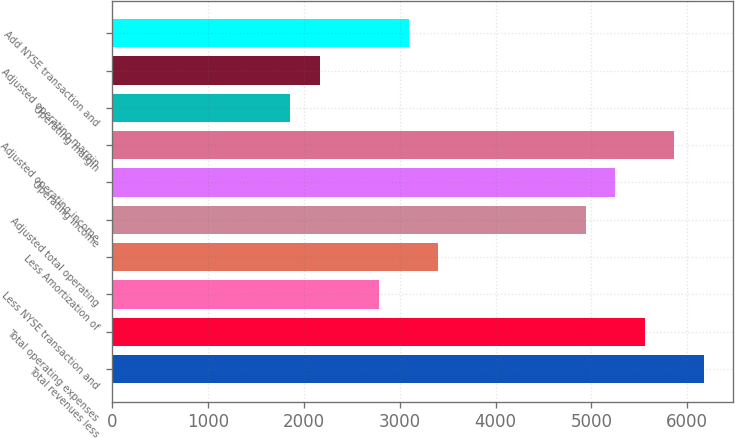<chart> <loc_0><loc_0><loc_500><loc_500><bar_chart><fcel>Total revenues less<fcel>Total operating expenses<fcel>Less NYSE transaction and<fcel>Less Amortization of<fcel>Adjusted total operating<fcel>Operating income<fcel>Adjusted operating income<fcel>Operating margin<fcel>Adjusted operating margin<fcel>Add NYSE transaction and<nl><fcel>6175.5<fcel>5558.8<fcel>2783.65<fcel>3400.35<fcel>4942.1<fcel>5250.45<fcel>5867.15<fcel>1858.6<fcel>2166.95<fcel>3092<nl></chart> 